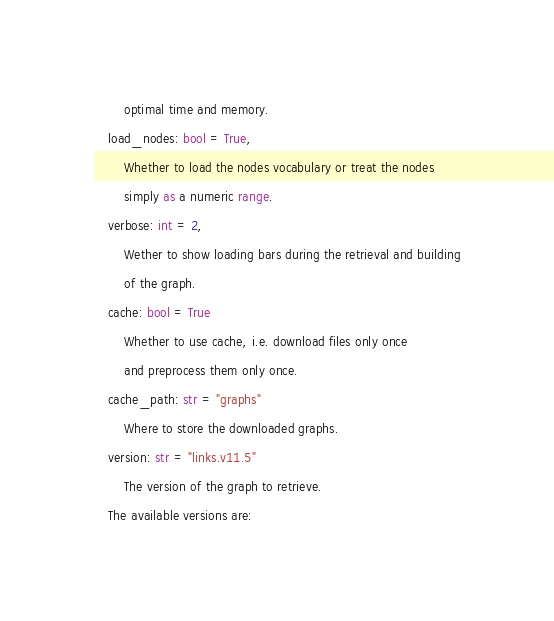Convert code to text. <code><loc_0><loc_0><loc_500><loc_500><_Python_>        optimal time and memory.
    load_nodes: bool = True,
        Whether to load the nodes vocabulary or treat the nodes
        simply as a numeric range.
    verbose: int = 2,
        Wether to show loading bars during the retrieval and building
        of the graph.
    cache: bool = True
        Whether to use cache, i.e. download files only once
        and preprocess them only once.
    cache_path: str = "graphs"
        Where to store the downloaded graphs.
    version: str = "links.v11.5"
        The version of the graph to retrieve.		
	The available versions are:</code> 